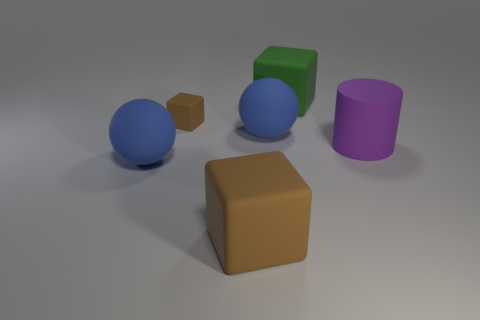Subtract 1 blocks. How many blocks are left? 2 Add 2 blue metallic blocks. How many objects exist? 8 Subtract all balls. How many objects are left? 4 Add 1 tiny brown matte objects. How many tiny brown matte objects are left? 2 Add 3 big brown blocks. How many big brown blocks exist? 4 Subtract 0 gray cylinders. How many objects are left? 6 Subtract all large purple things. Subtract all large blue objects. How many objects are left? 3 